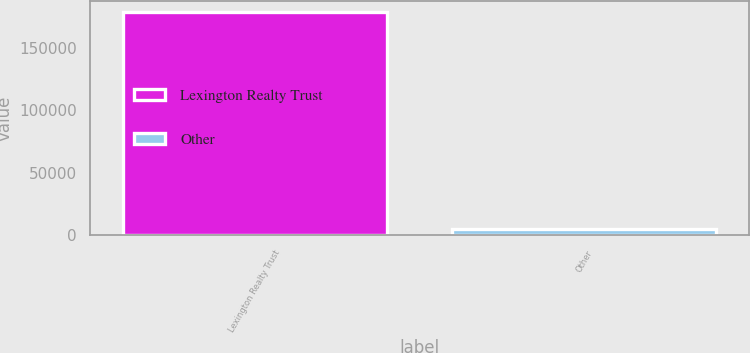Convert chart to OTSL. <chart><loc_0><loc_0><loc_500><loc_500><bar_chart><fcel>Lexington Realty Trust<fcel>Other<nl><fcel>178226<fcel>4526<nl></chart> 